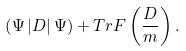<formula> <loc_0><loc_0><loc_500><loc_500>\left ( \Psi \left | D \right | \Psi \right ) + T r F \left ( \frac { D } { m } \right ) .</formula> 